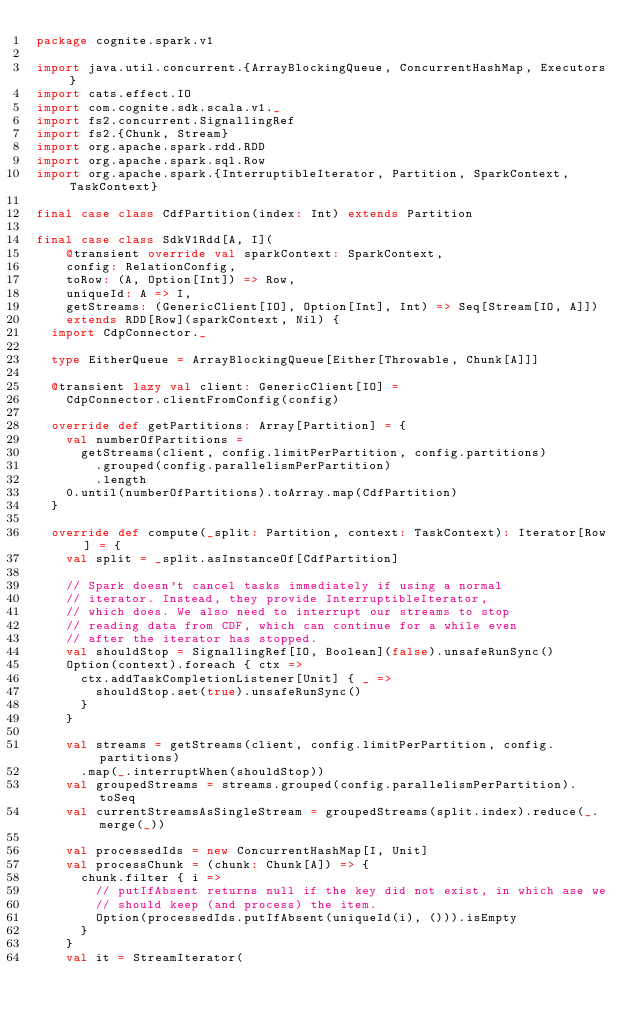<code> <loc_0><loc_0><loc_500><loc_500><_Scala_>package cognite.spark.v1

import java.util.concurrent.{ArrayBlockingQueue, ConcurrentHashMap, Executors}
import cats.effect.IO
import com.cognite.sdk.scala.v1._
import fs2.concurrent.SignallingRef
import fs2.{Chunk, Stream}
import org.apache.spark.rdd.RDD
import org.apache.spark.sql.Row
import org.apache.spark.{InterruptibleIterator, Partition, SparkContext, TaskContext}

final case class CdfPartition(index: Int) extends Partition

final case class SdkV1Rdd[A, I](
    @transient override val sparkContext: SparkContext,
    config: RelationConfig,
    toRow: (A, Option[Int]) => Row,
    uniqueId: A => I,
    getStreams: (GenericClient[IO], Option[Int], Int) => Seq[Stream[IO, A]])
    extends RDD[Row](sparkContext, Nil) {
  import CdpConnector._

  type EitherQueue = ArrayBlockingQueue[Either[Throwable, Chunk[A]]]

  @transient lazy val client: GenericClient[IO] =
    CdpConnector.clientFromConfig(config)

  override def getPartitions: Array[Partition] = {
    val numberOfPartitions =
      getStreams(client, config.limitPerPartition, config.partitions)
        .grouped(config.parallelismPerPartition)
        .length
    0.until(numberOfPartitions).toArray.map(CdfPartition)
  }

  override def compute(_split: Partition, context: TaskContext): Iterator[Row] = {
    val split = _split.asInstanceOf[CdfPartition]

    // Spark doesn't cancel tasks immediately if using a normal
    // iterator. Instead, they provide InterruptibleIterator,
    // which does. We also need to interrupt our streams to stop
    // reading data from CDF, which can continue for a while even
    // after the iterator has stopped.
    val shouldStop = SignallingRef[IO, Boolean](false).unsafeRunSync()
    Option(context).foreach { ctx =>
      ctx.addTaskCompletionListener[Unit] { _ =>
        shouldStop.set(true).unsafeRunSync()
      }
    }

    val streams = getStreams(client, config.limitPerPartition, config.partitions)
      .map(_.interruptWhen(shouldStop))
    val groupedStreams = streams.grouped(config.parallelismPerPartition).toSeq
    val currentStreamsAsSingleStream = groupedStreams(split.index).reduce(_.merge(_))

    val processedIds = new ConcurrentHashMap[I, Unit]
    val processChunk = (chunk: Chunk[A]) => {
      chunk.filter { i =>
        // putIfAbsent returns null if the key did not exist, in which ase we
        // should keep (and process) the item.
        Option(processedIds.putIfAbsent(uniqueId(i), ())).isEmpty
      }
    }
    val it = StreamIterator(</code> 